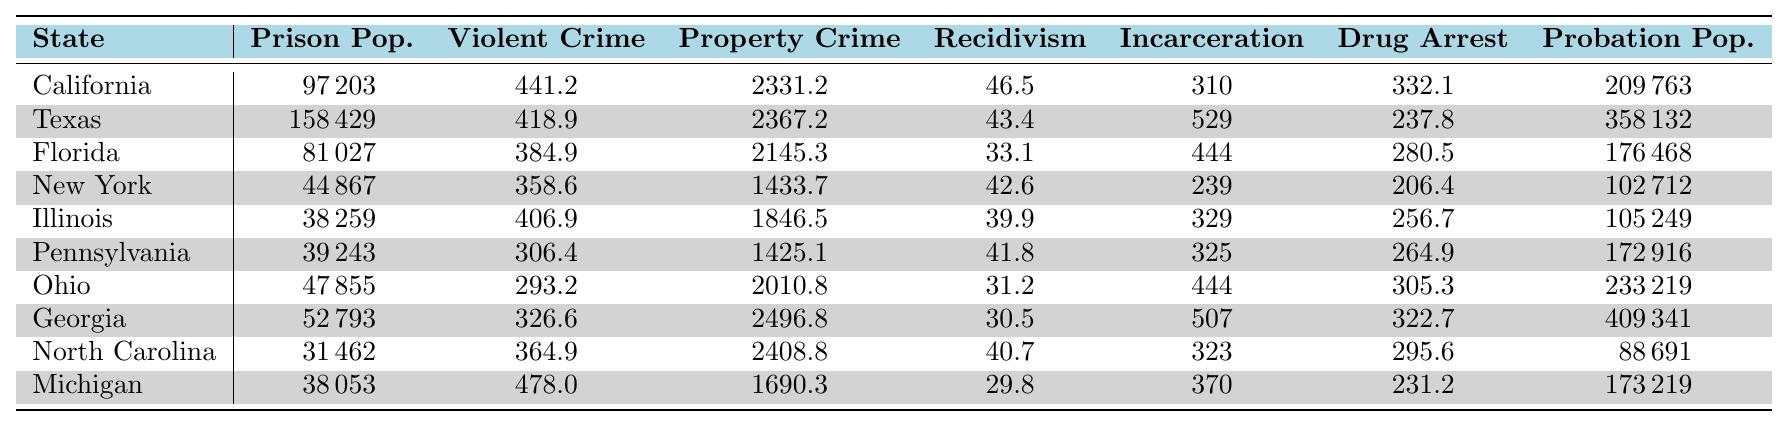What is the prison population of Texas? The table shows the specific value for the prison population under the column labeled "Prison Population" for Texas. The value listed is 158,429.
Answer: 158429 Which state has the highest violent crime rate? By examining the "Violent Crime Rate" column, California has the highest value at 441.2 compared to all other states listed.
Answer: California What is the difference in the property crime rates between Florida and New York? The property crime rate for Florida is 2,145.3 and for New York, it is 1,433.7. To find the difference, subtract New York's rate from Florida's rate: 2,145.3 - 1,433.7 = 711.6.
Answer: 711.6 Is the recidivism rate in Georgia higher than in Ohio? The recidivism rate for Georgia is 30.5 while for Ohio it is 31.2. Comparing these two values shows that Ohio has a higher rate; therefore, the answer is no.
Answer: No What is the average incarceration rate for the ten states listed? To find the average incarceration rate, add all states' rates: 310 (California) + 529 (Texas) + 444 (Florida) + 239 (New York) + 329 (Illinois) + 325 (Pennsylvania) + 444 (Ohio) + 507 (Georgia) + 323 (North Carolina) + 370 (Michigan) =  3,240. Then divide by 10 states: 3,240 / 10 = 324.
Answer: 324 Which state has the lowest drug arrest rate? Comparing the "Drug Arrest Rate" column, we see that Texas has the lowest value at 237.8, which is lower than the other listed states.
Answer: Texas Is the total probation population in California and Texas greater than that of Florida and New York combined? The total probation population for California is 209,763 and Texas is 358,132. Adding these gives 567,895. For Florida, the value is 176,468 and for New York, 102,712. Adding these gives 279,180. Comparing both sums: 567,895 > 279,180, thus yes.
Answer: Yes What is the highest recidivism rate among the states listed? The table shows the recidivism rates for all states, and California has the highest value at 46.5 among them.
Answer: California How many more drug arrests per capita does Georgia have compared to Florida? Georgia's drug arrest rate is 322.7, and Florida's is 280.5. Subtracting gives: 322.7 - 280.5 = 42.2.
Answer: 42.2 What is the total prison population for Illinois and Pennsylvania combined? The prison population for Illinois is 38,259 and for Pennsylvania, it is 39,243. Adding these values gives 38,259 + 39,243 = 77,502.
Answer: 77502 